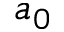Convert formula to latex. <formula><loc_0><loc_0><loc_500><loc_500>a _ { 0 }</formula> 